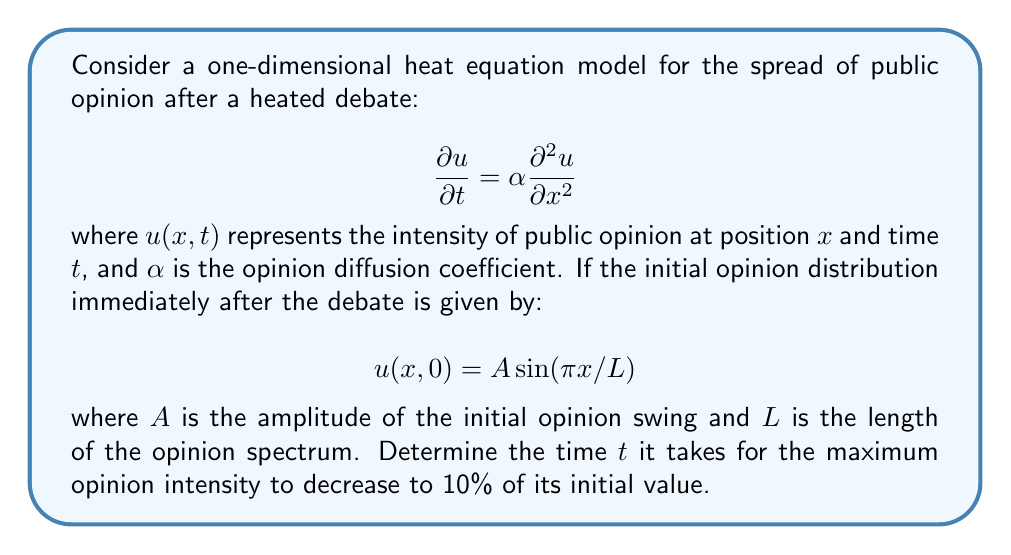What is the answer to this math problem? Let's approach this step-by-step:

1) The general solution to the heat equation with the given initial condition is:

   $$u(x,t) = A \sin(\pi x/L) e^{-\alpha (\pi/L)^2 t}$$

2) The maximum opinion intensity occurs at the peak of the sine wave, where $\sin(\pi x/L) = 1$. So, the maximum intensity at any time $t$ is:

   $$u_{max}(t) = A e^{-\alpha (\pi/L)^2 t}$$

3) We want to find the time $t$ when this maximum intensity decreases to 10% of its initial value:

   $$A e^{-\alpha (\pi/L)^2 t} = 0.1A$$

4) Dividing both sides by $A$:

   $$e^{-\alpha (\pi/L)^2 t} = 0.1$$

5) Taking the natural logarithm of both sides:

   $$-\alpha (\pi/L)^2 t = \ln(0.1)$$

6) Solving for $t$:

   $$t = -\frac{L^2}{\alpha \pi^2} \ln(0.1)$$

7) Simplifying:

   $$t = \frac{L^2}{\alpha \pi^2} \ln(10)$$

This gives us the time it takes for the maximum opinion intensity to decrease to 10% of its initial value.
Answer: $$t = \frac{L^2}{\alpha \pi^2} \ln(10)$$ 